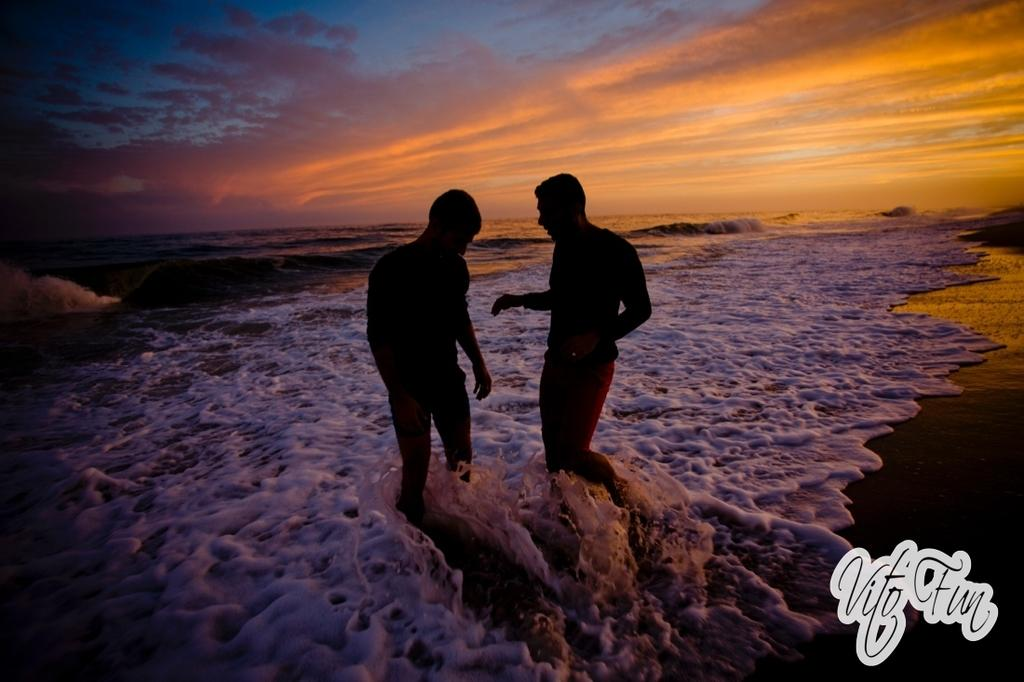How many people are in the water in the image? There are two persons standing in the water in the image. What can be seen in the background of the image? There is sky visible in the background of the image. Is there any text or marking in the image? Yes, there is a watermark in the right bottom corner of the image. What type of curve can be seen in the harbor in the image? There is no harbor present in the image, so it is not possible to determine if there is a curve or not. 